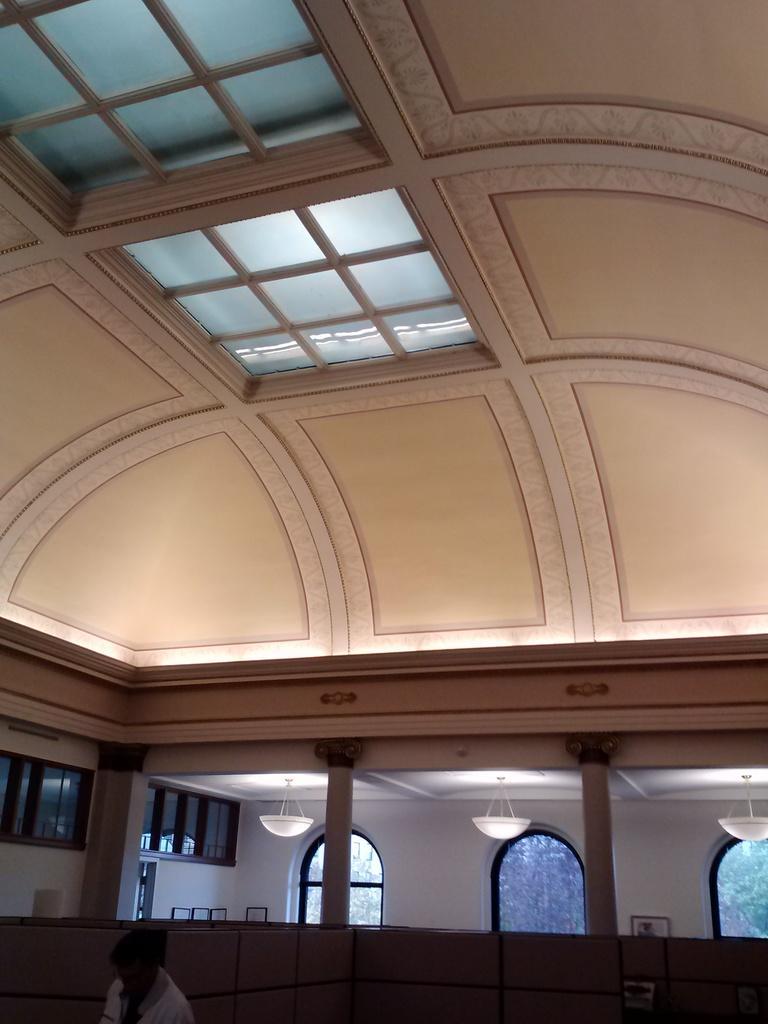Could you give a brief overview of what you see in this image? In this picture, we can see an inner view of a room, we can see a person, pillars, wall with glass doors, and some objects, we can see lights, roof with glass and some objects attached to it. 